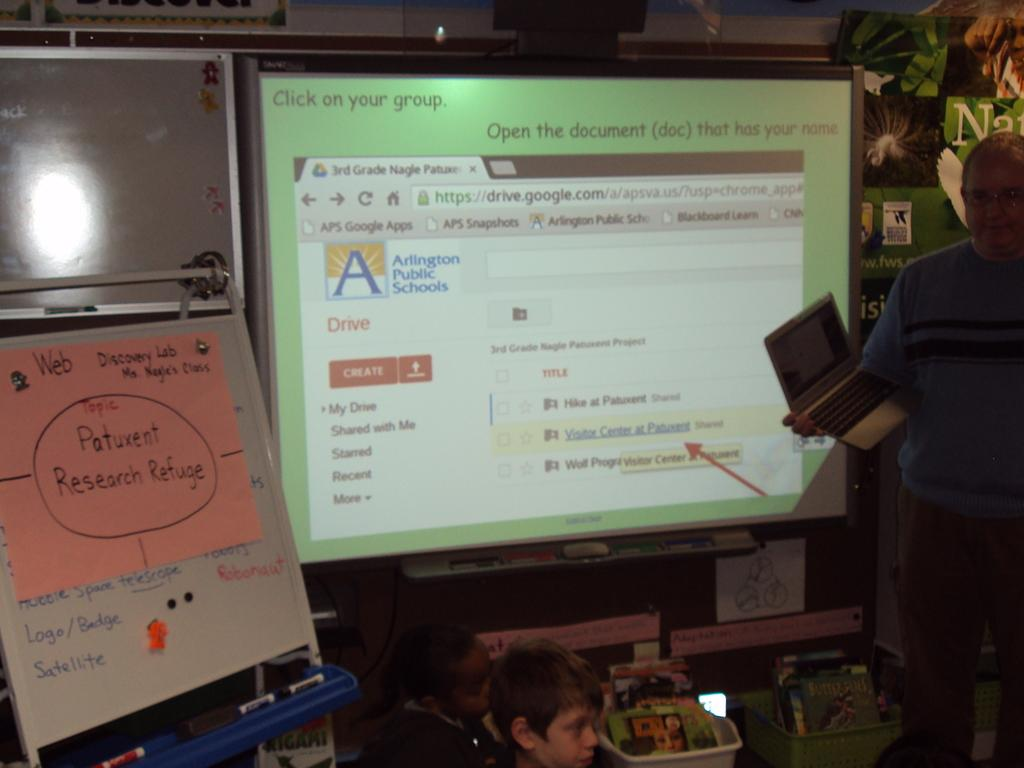<image>
Provide a brief description of the given image. An arlington public school google drive page is shown on the projector. 